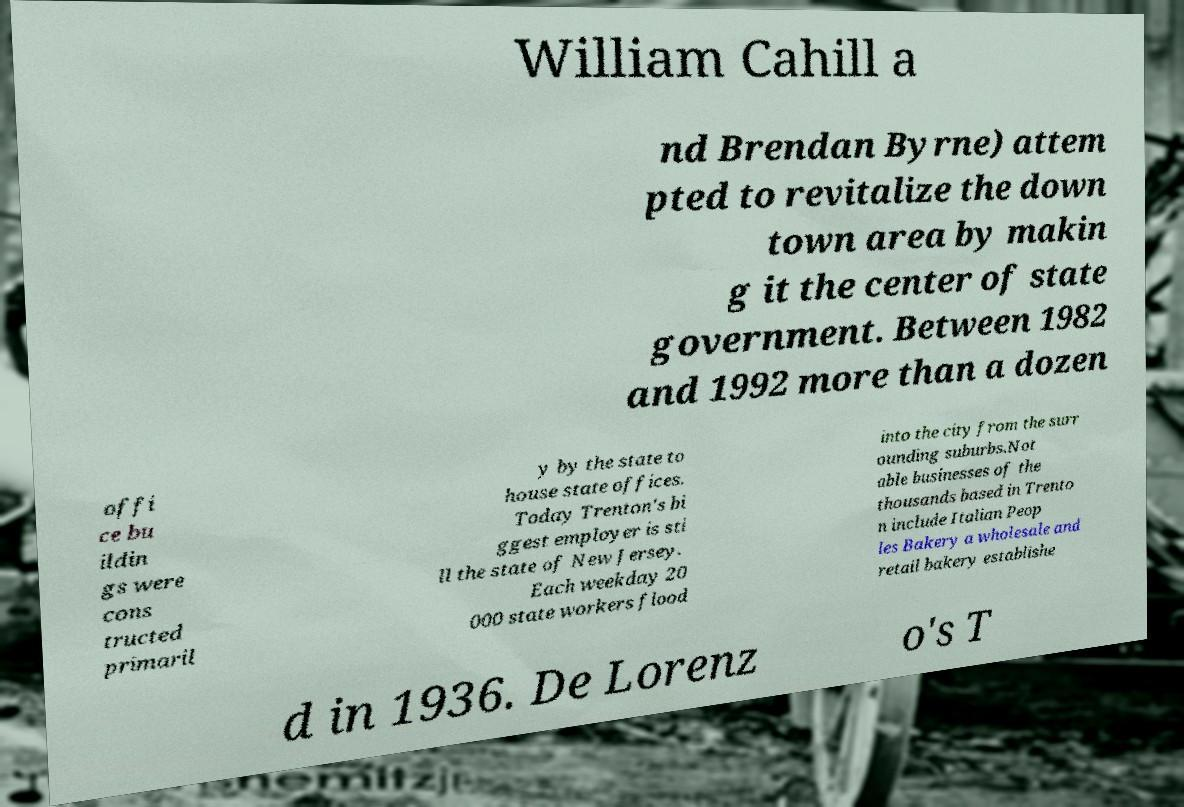For documentation purposes, I need the text within this image transcribed. Could you provide that? William Cahill a nd Brendan Byrne) attem pted to revitalize the down town area by makin g it the center of state government. Between 1982 and 1992 more than a dozen offi ce bu ildin gs were cons tructed primaril y by the state to house state offices. Today Trenton's bi ggest employer is sti ll the state of New Jersey. Each weekday 20 000 state workers flood into the city from the surr ounding suburbs.Not able businesses of the thousands based in Trento n include Italian Peop les Bakery a wholesale and retail bakery establishe d in 1936. De Lorenz o's T 